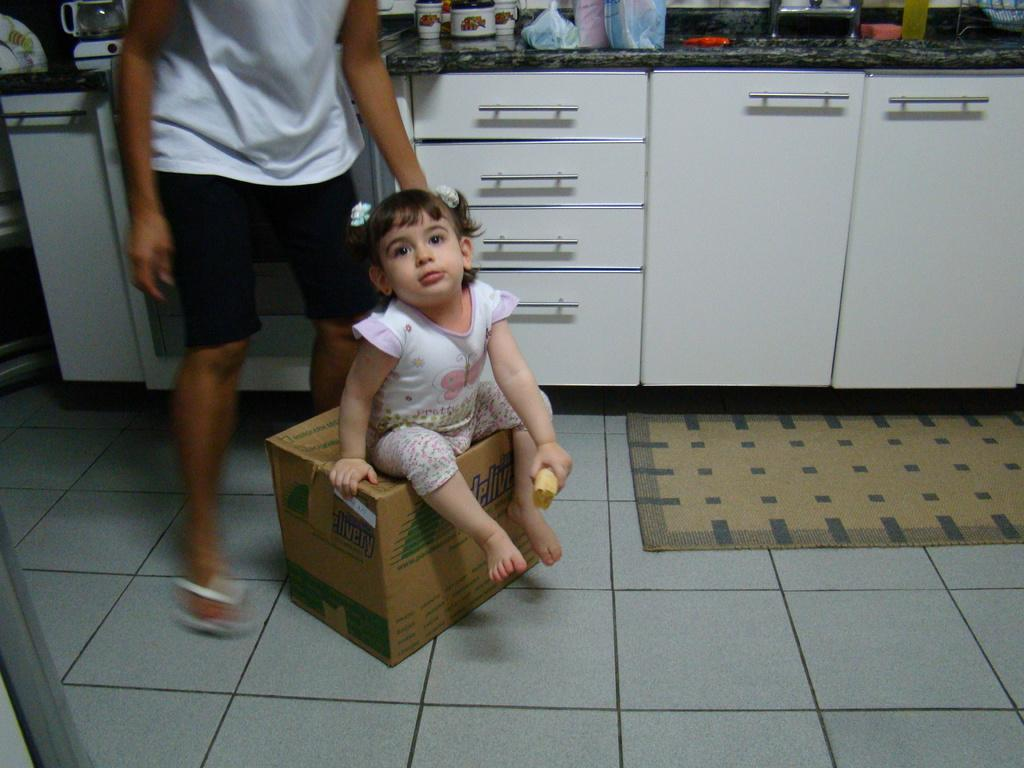Provide a one-sentence caption for the provided image. a girl sitting on a cardboard box labeled 'delivery'. 